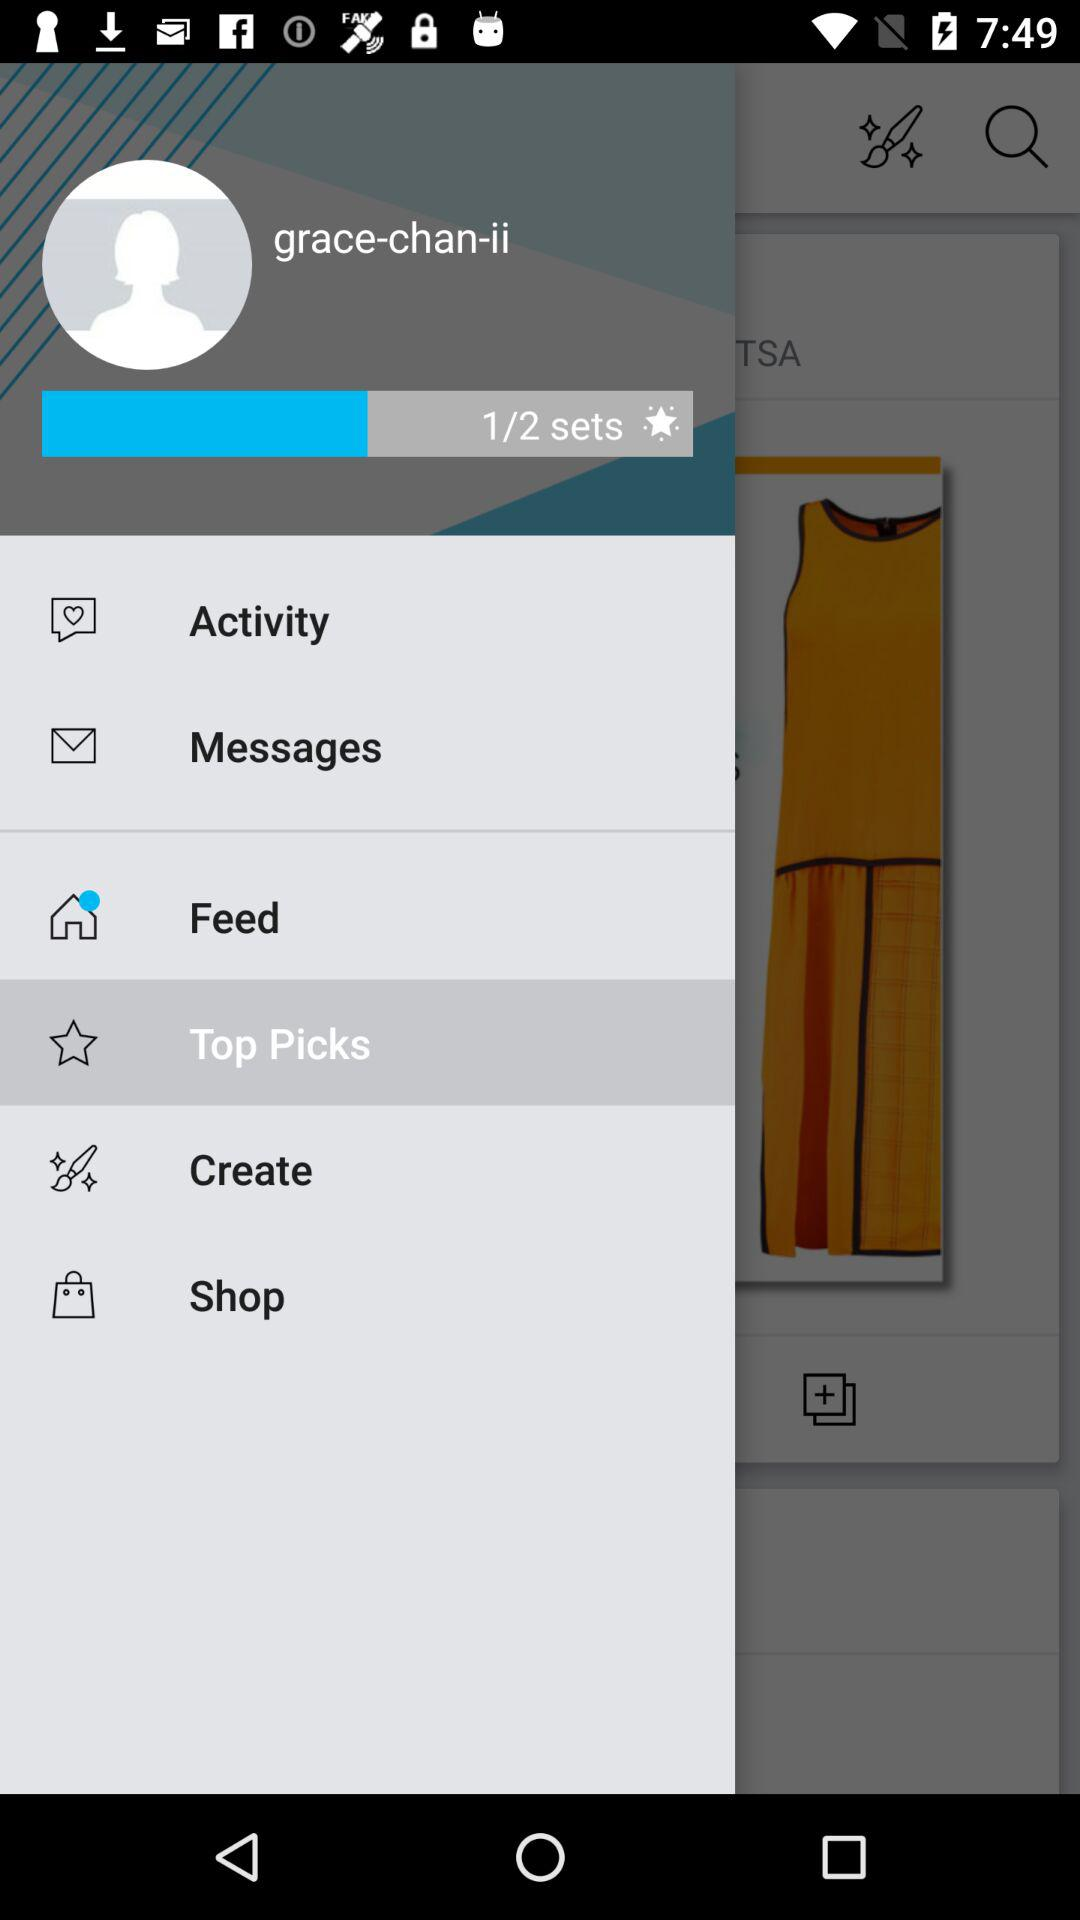How many more sets do I have to create to reach 2 sets?
Answer the question using a single word or phrase. 1 